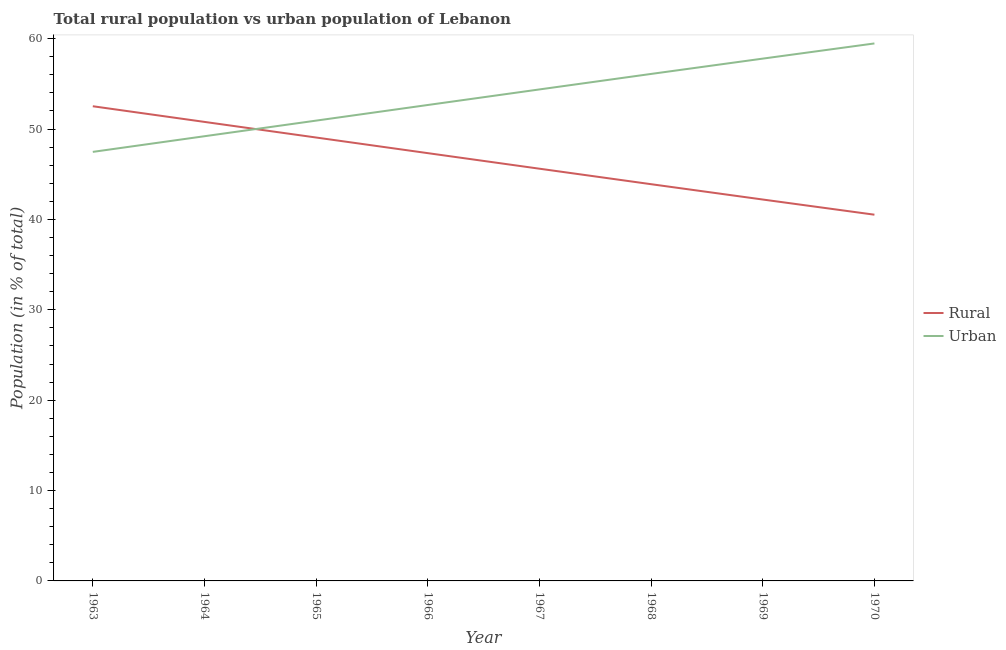How many different coloured lines are there?
Your answer should be compact. 2. Does the line corresponding to urban population intersect with the line corresponding to rural population?
Provide a succinct answer. Yes. Is the number of lines equal to the number of legend labels?
Ensure brevity in your answer.  Yes. What is the urban population in 1964?
Offer a terse response. 49.21. Across all years, what is the maximum rural population?
Provide a succinct answer. 52.52. Across all years, what is the minimum rural population?
Your answer should be compact. 40.52. In which year was the rural population maximum?
Provide a short and direct response. 1963. What is the total urban population in the graph?
Offer a very short reply. 428.04. What is the difference between the rural population in 1964 and that in 1970?
Provide a short and direct response. 10.27. What is the difference between the rural population in 1965 and the urban population in 1963?
Your answer should be compact. 1.59. What is the average rural population per year?
Your answer should be very brief. 46.5. In the year 1963, what is the difference between the rural population and urban population?
Make the answer very short. 5.05. In how many years, is the rural population greater than 42 %?
Your response must be concise. 7. What is the ratio of the urban population in 1965 to that in 1968?
Give a very brief answer. 0.91. Is the difference between the urban population in 1968 and 1969 greater than the difference between the rural population in 1968 and 1969?
Keep it short and to the point. No. What is the difference between the highest and the second highest urban population?
Provide a succinct answer. 1.68. In how many years, is the urban population greater than the average urban population taken over all years?
Offer a very short reply. 4. Is the sum of the rural population in 1963 and 1964 greater than the maximum urban population across all years?
Provide a succinct answer. Yes. Does the rural population monotonically increase over the years?
Provide a short and direct response. No. How many lines are there?
Your answer should be compact. 2. How many years are there in the graph?
Provide a succinct answer. 8. What is the difference between two consecutive major ticks on the Y-axis?
Your answer should be very brief. 10. Are the values on the major ticks of Y-axis written in scientific E-notation?
Give a very brief answer. No. Does the graph contain grids?
Keep it short and to the point. No. Where does the legend appear in the graph?
Ensure brevity in your answer.  Center right. How many legend labels are there?
Provide a short and direct response. 2. What is the title of the graph?
Ensure brevity in your answer.  Total rural population vs urban population of Lebanon. Does "Female entrants" appear as one of the legend labels in the graph?
Offer a terse response. No. What is the label or title of the X-axis?
Make the answer very short. Year. What is the label or title of the Y-axis?
Your answer should be very brief. Population (in % of total). What is the Population (in % of total) of Rural in 1963?
Make the answer very short. 52.52. What is the Population (in % of total) of Urban in 1963?
Offer a very short reply. 47.48. What is the Population (in % of total) of Rural in 1964?
Your response must be concise. 50.79. What is the Population (in % of total) in Urban in 1964?
Keep it short and to the point. 49.21. What is the Population (in % of total) in Rural in 1965?
Give a very brief answer. 49.06. What is the Population (in % of total) of Urban in 1965?
Your response must be concise. 50.94. What is the Population (in % of total) of Rural in 1966?
Keep it short and to the point. 47.34. What is the Population (in % of total) of Urban in 1966?
Your answer should be compact. 52.66. What is the Population (in % of total) in Rural in 1967?
Provide a succinct answer. 45.61. What is the Population (in % of total) in Urban in 1967?
Offer a terse response. 54.39. What is the Population (in % of total) in Rural in 1968?
Provide a short and direct response. 43.9. What is the Population (in % of total) in Urban in 1968?
Make the answer very short. 56.1. What is the Population (in % of total) of Rural in 1969?
Provide a succinct answer. 42.2. What is the Population (in % of total) in Urban in 1969?
Give a very brief answer. 57.8. What is the Population (in % of total) in Rural in 1970?
Offer a very short reply. 40.52. What is the Population (in % of total) in Urban in 1970?
Make the answer very short. 59.48. Across all years, what is the maximum Population (in % of total) of Rural?
Give a very brief answer. 52.52. Across all years, what is the maximum Population (in % of total) of Urban?
Provide a short and direct response. 59.48. Across all years, what is the minimum Population (in % of total) of Rural?
Make the answer very short. 40.52. Across all years, what is the minimum Population (in % of total) in Urban?
Keep it short and to the point. 47.48. What is the total Population (in % of total) of Rural in the graph?
Your response must be concise. 371.96. What is the total Population (in % of total) in Urban in the graph?
Keep it short and to the point. 428.04. What is the difference between the Population (in % of total) in Rural in 1963 and that in 1964?
Your answer should be very brief. 1.73. What is the difference between the Population (in % of total) of Urban in 1963 and that in 1964?
Provide a short and direct response. -1.73. What is the difference between the Population (in % of total) in Rural in 1963 and that in 1965?
Your answer should be very brief. 3.46. What is the difference between the Population (in % of total) in Urban in 1963 and that in 1965?
Provide a short and direct response. -3.46. What is the difference between the Population (in % of total) of Rural in 1963 and that in 1966?
Your response must be concise. 5.19. What is the difference between the Population (in % of total) in Urban in 1963 and that in 1966?
Offer a very short reply. -5.19. What is the difference between the Population (in % of total) in Rural in 1963 and that in 1967?
Offer a terse response. 6.91. What is the difference between the Population (in % of total) in Urban in 1963 and that in 1967?
Make the answer very short. -6.91. What is the difference between the Population (in % of total) in Rural in 1963 and that in 1968?
Offer a terse response. 8.63. What is the difference between the Population (in % of total) in Urban in 1963 and that in 1968?
Your response must be concise. -8.63. What is the difference between the Population (in % of total) in Rural in 1963 and that in 1969?
Ensure brevity in your answer.  10.32. What is the difference between the Population (in % of total) of Urban in 1963 and that in 1969?
Your answer should be compact. -10.32. What is the difference between the Population (in % of total) in Rural in 1964 and that in 1965?
Your answer should be very brief. 1.73. What is the difference between the Population (in % of total) of Urban in 1964 and that in 1965?
Offer a very short reply. -1.73. What is the difference between the Population (in % of total) in Rural in 1964 and that in 1966?
Give a very brief answer. 3.46. What is the difference between the Population (in % of total) of Urban in 1964 and that in 1966?
Provide a succinct answer. -3.46. What is the difference between the Population (in % of total) of Rural in 1964 and that in 1967?
Ensure brevity in your answer.  5.18. What is the difference between the Population (in % of total) in Urban in 1964 and that in 1967?
Ensure brevity in your answer.  -5.18. What is the difference between the Population (in % of total) in Rural in 1964 and that in 1968?
Give a very brief answer. 6.89. What is the difference between the Population (in % of total) of Urban in 1964 and that in 1968?
Give a very brief answer. -6.89. What is the difference between the Population (in % of total) of Rural in 1964 and that in 1969?
Ensure brevity in your answer.  8.59. What is the difference between the Population (in % of total) in Urban in 1964 and that in 1969?
Your response must be concise. -8.59. What is the difference between the Population (in % of total) of Rural in 1964 and that in 1970?
Make the answer very short. 10.27. What is the difference between the Population (in % of total) of Urban in 1964 and that in 1970?
Ensure brevity in your answer.  -10.27. What is the difference between the Population (in % of total) in Rural in 1965 and that in 1966?
Give a very brief answer. 1.73. What is the difference between the Population (in % of total) of Urban in 1965 and that in 1966?
Provide a short and direct response. -1.73. What is the difference between the Population (in % of total) in Rural in 1965 and that in 1967?
Provide a short and direct response. 3.45. What is the difference between the Population (in % of total) of Urban in 1965 and that in 1967?
Your response must be concise. -3.45. What is the difference between the Population (in % of total) in Rural in 1965 and that in 1968?
Offer a very short reply. 5.17. What is the difference between the Population (in % of total) in Urban in 1965 and that in 1968?
Your answer should be compact. -5.17. What is the difference between the Population (in % of total) of Rural in 1965 and that in 1969?
Your answer should be compact. 6.86. What is the difference between the Population (in % of total) of Urban in 1965 and that in 1969?
Give a very brief answer. -6.86. What is the difference between the Population (in % of total) of Rural in 1965 and that in 1970?
Keep it short and to the point. 8.54. What is the difference between the Population (in % of total) of Urban in 1965 and that in 1970?
Your response must be concise. -8.54. What is the difference between the Population (in % of total) in Rural in 1966 and that in 1967?
Provide a succinct answer. 1.72. What is the difference between the Population (in % of total) of Urban in 1966 and that in 1967?
Keep it short and to the point. -1.72. What is the difference between the Population (in % of total) in Rural in 1966 and that in 1968?
Your answer should be very brief. 3.44. What is the difference between the Population (in % of total) of Urban in 1966 and that in 1968?
Keep it short and to the point. -3.44. What is the difference between the Population (in % of total) of Rural in 1966 and that in 1969?
Ensure brevity in your answer.  5.13. What is the difference between the Population (in % of total) of Urban in 1966 and that in 1969?
Your answer should be very brief. -5.13. What is the difference between the Population (in % of total) of Rural in 1966 and that in 1970?
Your answer should be compact. 6.81. What is the difference between the Population (in % of total) of Urban in 1966 and that in 1970?
Ensure brevity in your answer.  -6.81. What is the difference between the Population (in % of total) of Rural in 1967 and that in 1968?
Keep it short and to the point. 1.72. What is the difference between the Population (in % of total) of Urban in 1967 and that in 1968?
Offer a very short reply. -1.72. What is the difference between the Population (in % of total) of Rural in 1967 and that in 1969?
Offer a very short reply. 3.41. What is the difference between the Population (in % of total) in Urban in 1967 and that in 1969?
Your response must be concise. -3.41. What is the difference between the Population (in % of total) in Rural in 1967 and that in 1970?
Offer a very short reply. 5.09. What is the difference between the Population (in % of total) of Urban in 1967 and that in 1970?
Ensure brevity in your answer.  -5.09. What is the difference between the Population (in % of total) in Rural in 1968 and that in 1969?
Your answer should be compact. 1.7. What is the difference between the Population (in % of total) of Urban in 1968 and that in 1969?
Your response must be concise. -1.7. What is the difference between the Population (in % of total) of Rural in 1968 and that in 1970?
Offer a terse response. 3.37. What is the difference between the Population (in % of total) of Urban in 1968 and that in 1970?
Give a very brief answer. -3.37. What is the difference between the Population (in % of total) in Rural in 1969 and that in 1970?
Your answer should be compact. 1.68. What is the difference between the Population (in % of total) in Urban in 1969 and that in 1970?
Make the answer very short. -1.68. What is the difference between the Population (in % of total) in Rural in 1963 and the Population (in % of total) in Urban in 1964?
Your answer should be very brief. 3.32. What is the difference between the Population (in % of total) of Rural in 1963 and the Population (in % of total) of Urban in 1965?
Your response must be concise. 1.59. What is the difference between the Population (in % of total) of Rural in 1963 and the Population (in % of total) of Urban in 1966?
Provide a short and direct response. -0.14. What is the difference between the Population (in % of total) of Rural in 1963 and the Population (in % of total) of Urban in 1967?
Make the answer very short. -1.86. What is the difference between the Population (in % of total) of Rural in 1963 and the Population (in % of total) of Urban in 1968?
Your answer should be very brief. -3.58. What is the difference between the Population (in % of total) of Rural in 1963 and the Population (in % of total) of Urban in 1969?
Offer a very short reply. -5.27. What is the difference between the Population (in % of total) of Rural in 1963 and the Population (in % of total) of Urban in 1970?
Keep it short and to the point. -6.95. What is the difference between the Population (in % of total) of Rural in 1964 and the Population (in % of total) of Urban in 1965?
Make the answer very short. -0.14. What is the difference between the Population (in % of total) in Rural in 1964 and the Population (in % of total) in Urban in 1966?
Keep it short and to the point. -1.87. What is the difference between the Population (in % of total) in Rural in 1964 and the Population (in % of total) in Urban in 1967?
Offer a very short reply. -3.59. What is the difference between the Population (in % of total) in Rural in 1964 and the Population (in % of total) in Urban in 1968?
Offer a very short reply. -5.31. What is the difference between the Population (in % of total) in Rural in 1964 and the Population (in % of total) in Urban in 1969?
Offer a very short reply. -7. What is the difference between the Population (in % of total) in Rural in 1964 and the Population (in % of total) in Urban in 1970?
Give a very brief answer. -8.68. What is the difference between the Population (in % of total) in Rural in 1965 and the Population (in % of total) in Urban in 1966?
Ensure brevity in your answer.  -3.6. What is the difference between the Population (in % of total) in Rural in 1965 and the Population (in % of total) in Urban in 1967?
Your answer should be very brief. -5.32. What is the difference between the Population (in % of total) in Rural in 1965 and the Population (in % of total) in Urban in 1968?
Your answer should be compact. -7.04. What is the difference between the Population (in % of total) in Rural in 1965 and the Population (in % of total) in Urban in 1969?
Ensure brevity in your answer.  -8.73. What is the difference between the Population (in % of total) of Rural in 1965 and the Population (in % of total) of Urban in 1970?
Make the answer very short. -10.41. What is the difference between the Population (in % of total) in Rural in 1966 and the Population (in % of total) in Urban in 1967?
Your answer should be very brief. -7.05. What is the difference between the Population (in % of total) in Rural in 1966 and the Population (in % of total) in Urban in 1968?
Your answer should be compact. -8.77. What is the difference between the Population (in % of total) of Rural in 1966 and the Population (in % of total) of Urban in 1969?
Your response must be concise. -10.46. What is the difference between the Population (in % of total) of Rural in 1966 and the Population (in % of total) of Urban in 1970?
Provide a succinct answer. -12.14. What is the difference between the Population (in % of total) in Rural in 1967 and the Population (in % of total) in Urban in 1968?
Give a very brief answer. -10.49. What is the difference between the Population (in % of total) of Rural in 1967 and the Population (in % of total) of Urban in 1969?
Your response must be concise. -12.18. What is the difference between the Population (in % of total) of Rural in 1967 and the Population (in % of total) of Urban in 1970?
Provide a short and direct response. -13.86. What is the difference between the Population (in % of total) in Rural in 1968 and the Population (in % of total) in Urban in 1969?
Your response must be concise. -13.9. What is the difference between the Population (in % of total) of Rural in 1968 and the Population (in % of total) of Urban in 1970?
Your answer should be compact. -15.58. What is the difference between the Population (in % of total) in Rural in 1969 and the Population (in % of total) in Urban in 1970?
Your answer should be very brief. -17.27. What is the average Population (in % of total) in Rural per year?
Offer a terse response. 46.5. What is the average Population (in % of total) in Urban per year?
Keep it short and to the point. 53.5. In the year 1963, what is the difference between the Population (in % of total) in Rural and Population (in % of total) in Urban?
Give a very brief answer. 5.05. In the year 1964, what is the difference between the Population (in % of total) in Rural and Population (in % of total) in Urban?
Keep it short and to the point. 1.59. In the year 1965, what is the difference between the Population (in % of total) in Rural and Population (in % of total) in Urban?
Your answer should be compact. -1.87. In the year 1966, what is the difference between the Population (in % of total) of Rural and Population (in % of total) of Urban?
Your answer should be compact. -5.33. In the year 1967, what is the difference between the Population (in % of total) of Rural and Population (in % of total) of Urban?
Provide a succinct answer. -8.77. In the year 1968, what is the difference between the Population (in % of total) in Rural and Population (in % of total) in Urban?
Keep it short and to the point. -12.2. In the year 1969, what is the difference between the Population (in % of total) in Rural and Population (in % of total) in Urban?
Your answer should be very brief. -15.59. In the year 1970, what is the difference between the Population (in % of total) in Rural and Population (in % of total) in Urban?
Provide a short and direct response. -18.95. What is the ratio of the Population (in % of total) of Rural in 1963 to that in 1964?
Provide a succinct answer. 1.03. What is the ratio of the Population (in % of total) of Urban in 1963 to that in 1964?
Ensure brevity in your answer.  0.96. What is the ratio of the Population (in % of total) in Rural in 1963 to that in 1965?
Provide a short and direct response. 1.07. What is the ratio of the Population (in % of total) in Urban in 1963 to that in 1965?
Offer a terse response. 0.93. What is the ratio of the Population (in % of total) in Rural in 1963 to that in 1966?
Ensure brevity in your answer.  1.11. What is the ratio of the Population (in % of total) in Urban in 1963 to that in 1966?
Offer a very short reply. 0.9. What is the ratio of the Population (in % of total) of Rural in 1963 to that in 1967?
Offer a very short reply. 1.15. What is the ratio of the Population (in % of total) in Urban in 1963 to that in 1967?
Give a very brief answer. 0.87. What is the ratio of the Population (in % of total) in Rural in 1963 to that in 1968?
Your answer should be very brief. 1.2. What is the ratio of the Population (in % of total) in Urban in 1963 to that in 1968?
Offer a terse response. 0.85. What is the ratio of the Population (in % of total) in Rural in 1963 to that in 1969?
Your answer should be very brief. 1.24. What is the ratio of the Population (in % of total) in Urban in 1963 to that in 1969?
Your response must be concise. 0.82. What is the ratio of the Population (in % of total) of Rural in 1963 to that in 1970?
Make the answer very short. 1.3. What is the ratio of the Population (in % of total) of Urban in 1963 to that in 1970?
Your answer should be very brief. 0.8. What is the ratio of the Population (in % of total) in Rural in 1964 to that in 1965?
Your response must be concise. 1.04. What is the ratio of the Population (in % of total) in Urban in 1964 to that in 1965?
Give a very brief answer. 0.97. What is the ratio of the Population (in % of total) of Rural in 1964 to that in 1966?
Provide a short and direct response. 1.07. What is the ratio of the Population (in % of total) in Urban in 1964 to that in 1966?
Your answer should be very brief. 0.93. What is the ratio of the Population (in % of total) in Rural in 1964 to that in 1967?
Provide a succinct answer. 1.11. What is the ratio of the Population (in % of total) of Urban in 1964 to that in 1967?
Keep it short and to the point. 0.9. What is the ratio of the Population (in % of total) of Rural in 1964 to that in 1968?
Offer a terse response. 1.16. What is the ratio of the Population (in % of total) in Urban in 1964 to that in 1968?
Provide a succinct answer. 0.88. What is the ratio of the Population (in % of total) of Rural in 1964 to that in 1969?
Ensure brevity in your answer.  1.2. What is the ratio of the Population (in % of total) of Urban in 1964 to that in 1969?
Offer a very short reply. 0.85. What is the ratio of the Population (in % of total) of Rural in 1964 to that in 1970?
Make the answer very short. 1.25. What is the ratio of the Population (in % of total) of Urban in 1964 to that in 1970?
Provide a succinct answer. 0.83. What is the ratio of the Population (in % of total) in Rural in 1965 to that in 1966?
Give a very brief answer. 1.04. What is the ratio of the Population (in % of total) in Urban in 1965 to that in 1966?
Offer a terse response. 0.97. What is the ratio of the Population (in % of total) in Rural in 1965 to that in 1967?
Your answer should be compact. 1.08. What is the ratio of the Population (in % of total) in Urban in 1965 to that in 1967?
Give a very brief answer. 0.94. What is the ratio of the Population (in % of total) of Rural in 1965 to that in 1968?
Provide a succinct answer. 1.12. What is the ratio of the Population (in % of total) of Urban in 1965 to that in 1968?
Ensure brevity in your answer.  0.91. What is the ratio of the Population (in % of total) of Rural in 1965 to that in 1969?
Provide a short and direct response. 1.16. What is the ratio of the Population (in % of total) in Urban in 1965 to that in 1969?
Give a very brief answer. 0.88. What is the ratio of the Population (in % of total) of Rural in 1965 to that in 1970?
Offer a very short reply. 1.21. What is the ratio of the Population (in % of total) of Urban in 1965 to that in 1970?
Make the answer very short. 0.86. What is the ratio of the Population (in % of total) in Rural in 1966 to that in 1967?
Ensure brevity in your answer.  1.04. What is the ratio of the Population (in % of total) of Urban in 1966 to that in 1967?
Make the answer very short. 0.97. What is the ratio of the Population (in % of total) of Rural in 1966 to that in 1968?
Your answer should be very brief. 1.08. What is the ratio of the Population (in % of total) in Urban in 1966 to that in 1968?
Your answer should be compact. 0.94. What is the ratio of the Population (in % of total) in Rural in 1966 to that in 1969?
Give a very brief answer. 1.12. What is the ratio of the Population (in % of total) of Urban in 1966 to that in 1969?
Your answer should be very brief. 0.91. What is the ratio of the Population (in % of total) in Rural in 1966 to that in 1970?
Ensure brevity in your answer.  1.17. What is the ratio of the Population (in % of total) in Urban in 1966 to that in 1970?
Your response must be concise. 0.89. What is the ratio of the Population (in % of total) in Rural in 1967 to that in 1968?
Your answer should be very brief. 1.04. What is the ratio of the Population (in % of total) of Urban in 1967 to that in 1968?
Provide a short and direct response. 0.97. What is the ratio of the Population (in % of total) in Rural in 1967 to that in 1969?
Provide a succinct answer. 1.08. What is the ratio of the Population (in % of total) of Urban in 1967 to that in 1969?
Make the answer very short. 0.94. What is the ratio of the Population (in % of total) of Rural in 1967 to that in 1970?
Offer a terse response. 1.13. What is the ratio of the Population (in % of total) of Urban in 1967 to that in 1970?
Offer a terse response. 0.91. What is the ratio of the Population (in % of total) of Rural in 1968 to that in 1969?
Provide a succinct answer. 1.04. What is the ratio of the Population (in % of total) of Urban in 1968 to that in 1969?
Offer a terse response. 0.97. What is the ratio of the Population (in % of total) of Rural in 1968 to that in 1970?
Offer a terse response. 1.08. What is the ratio of the Population (in % of total) in Urban in 1968 to that in 1970?
Give a very brief answer. 0.94. What is the ratio of the Population (in % of total) of Rural in 1969 to that in 1970?
Keep it short and to the point. 1.04. What is the ratio of the Population (in % of total) of Urban in 1969 to that in 1970?
Offer a terse response. 0.97. What is the difference between the highest and the second highest Population (in % of total) of Rural?
Provide a short and direct response. 1.73. What is the difference between the highest and the second highest Population (in % of total) of Urban?
Offer a terse response. 1.68. What is the difference between the highest and the lowest Population (in % of total) of Urban?
Provide a succinct answer. 12. 